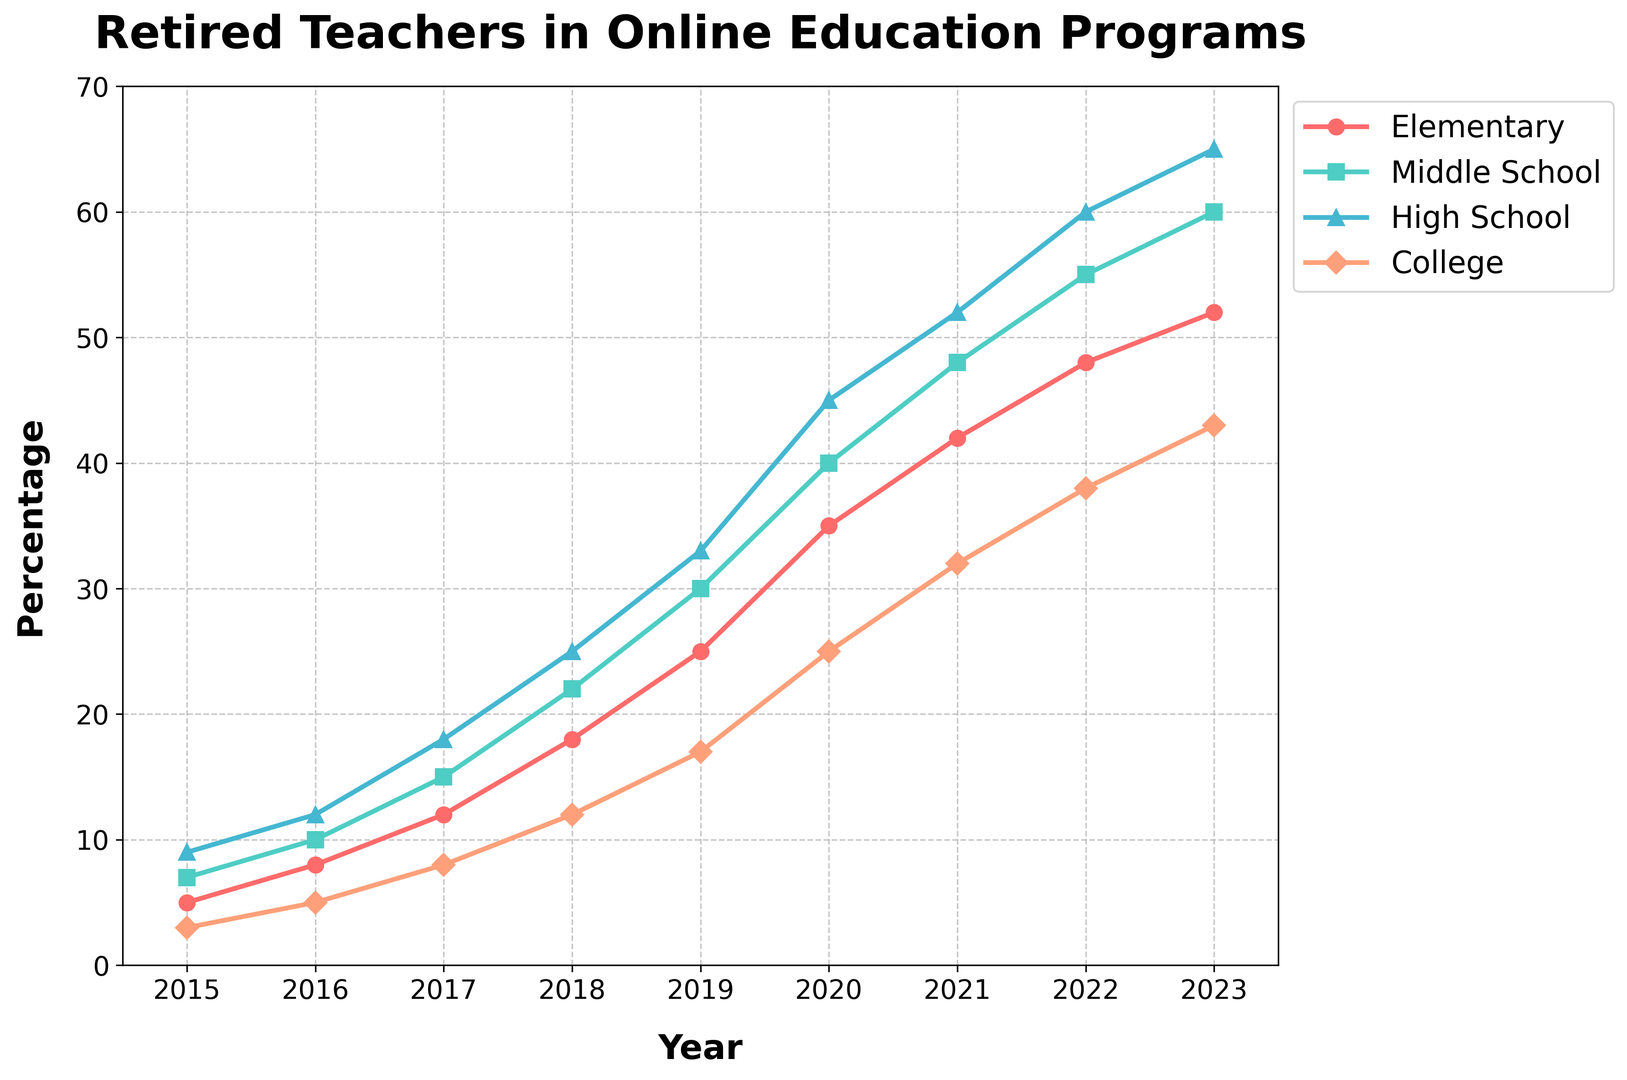What year had the highest percentage of retired teachers participating in online tutoring for high school students? Look at the line labeled "High School" and find the highest point. The year corresponding to this point is 2023, where the percentage is 65%.
Answer: 2023 By how much did the percentage of retired teachers tutoring middle school students increase from 2016 to 2021? Find the percentage for "Middle School" in 2016 and 2021. The values are 10% and 48%, respectively. Subtract 10 from 48 to find the increase: 48 - 10 = 38%.
Answer: 38% Which group had the smallest increase from 2015 to 2023? Calculate the difference for each group. For Elementary: 52 - 5 = 47, for Middle School: 60 - 7 = 53, for High School: 65 - 9 = 56, and for College: 43 - 3 = 40. The smallest increase is for College, which is 40%.
Answer: College What is the average percentage of retired teachers engaging in online programs for College over all the years? Add the percentages for College from all years and then divide by the number of years: (3 + 5 + 8 + 12 + 17 + 25 + 32 + 38 + 43)/9 = 20.33%.
Answer: 20.33% In which year did elementary school programs see a jump of more than 10% in participation? Examine the changes year by year for Elementary. From 2017 to 2018, the increase is 18 - 12 = 6%; from 2018 to 2019, the increase is 25 - 18 = 7%; from 2019 to 2020, the increase is 35 - 25 = 10%; from 2020 to 2021, the increase is 42 - 35 = 7%; and from 2021 to 2022, the increase is 48 - 42 = 6%. No year shows a jump of more than 10%.
Answer: None How much higher was the percentage of retired teachers engaged in online high school tutoring in 2023 compared to middle school tutoring in 2015? Compare the 2023 value for High School to the 2015 value for Middle School: 65% (High School 2023) - 7% (Middle School 2015) = 58%.
Answer: 58% Between which consecutive years does College have the largest increase in participation? Calculate the annual changes for College: from 2015 to 2016, 5 - 3 = 2%; from 2016 to 2017, 8 - 5 = 3%; from 2017 to 2018, 12 - 8 = 4%; from 2018 to 2019, 17 - 12 = 5%; from 2019 to 2020, 25 - 17 = 8%; from 2020 to 2021, 32 - 25 = 7%; from 2021 to 2022, 38 - 32 = 6%; and from 2022 to 2023, 43 - 38 = 5%. The largest increase is from 2019 to 2020 (8%).
Answer: 2019 to 2020 